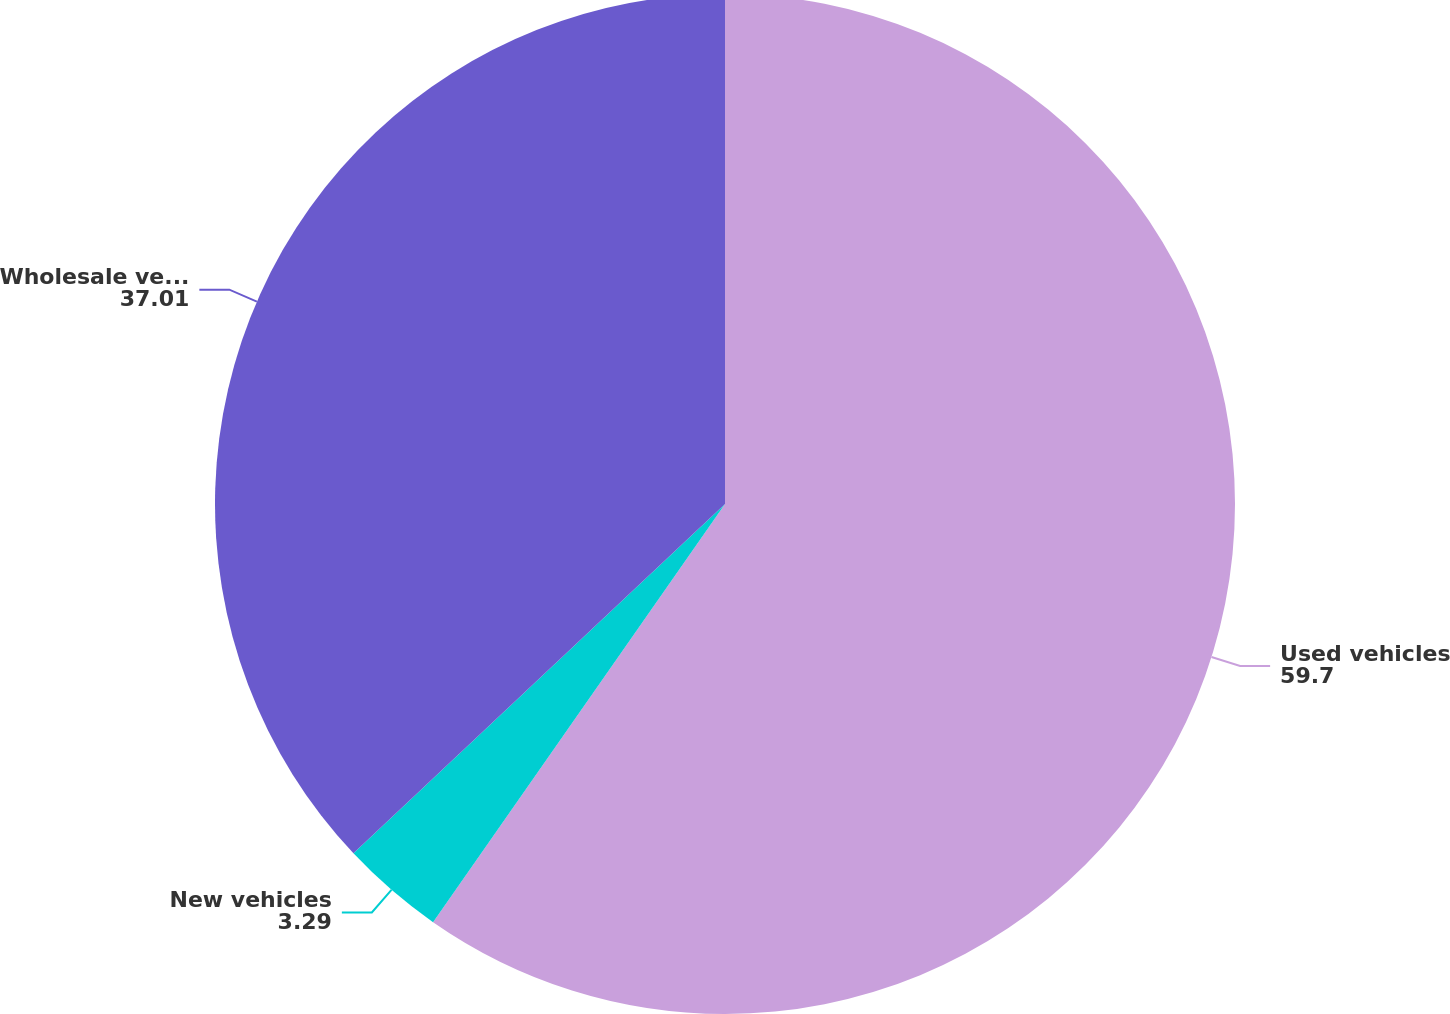Convert chart to OTSL. <chart><loc_0><loc_0><loc_500><loc_500><pie_chart><fcel>Used vehicles<fcel>New vehicles<fcel>Wholesale vehicles<nl><fcel>59.7%<fcel>3.29%<fcel>37.01%<nl></chart> 